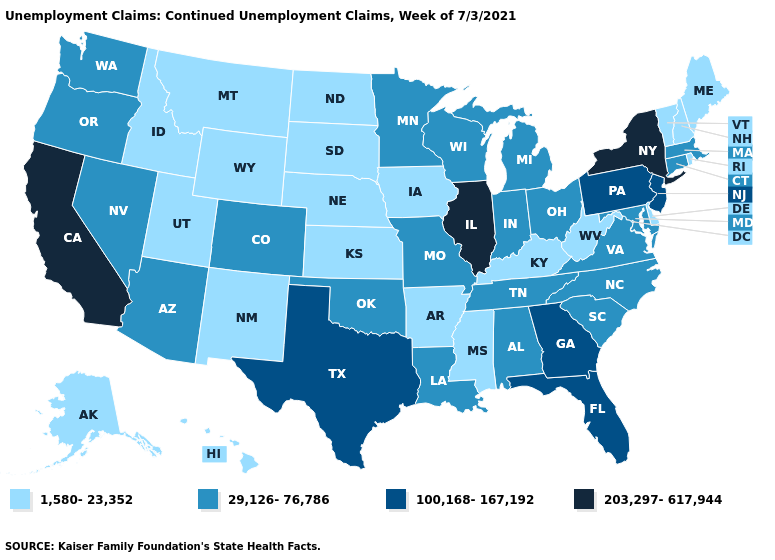What is the highest value in the South ?
Short answer required. 100,168-167,192. How many symbols are there in the legend?
Concise answer only. 4. Name the states that have a value in the range 100,168-167,192?
Quick response, please. Florida, Georgia, New Jersey, Pennsylvania, Texas. Among the states that border Idaho , does Montana have the highest value?
Keep it brief. No. Does West Virginia have the same value as Georgia?
Write a very short answer. No. Name the states that have a value in the range 203,297-617,944?
Keep it brief. California, Illinois, New York. Does Connecticut have a higher value than Florida?
Quick response, please. No. What is the value of Minnesota?
Concise answer only. 29,126-76,786. What is the value of Connecticut?
Short answer required. 29,126-76,786. Name the states that have a value in the range 203,297-617,944?
Concise answer only. California, Illinois, New York. Name the states that have a value in the range 203,297-617,944?
Quick response, please. California, Illinois, New York. What is the lowest value in the South?
Write a very short answer. 1,580-23,352. Does California have the highest value in the USA?
Be succinct. Yes. Name the states that have a value in the range 1,580-23,352?
Give a very brief answer. Alaska, Arkansas, Delaware, Hawaii, Idaho, Iowa, Kansas, Kentucky, Maine, Mississippi, Montana, Nebraska, New Hampshire, New Mexico, North Dakota, Rhode Island, South Dakota, Utah, Vermont, West Virginia, Wyoming. What is the value of Georgia?
Give a very brief answer. 100,168-167,192. 